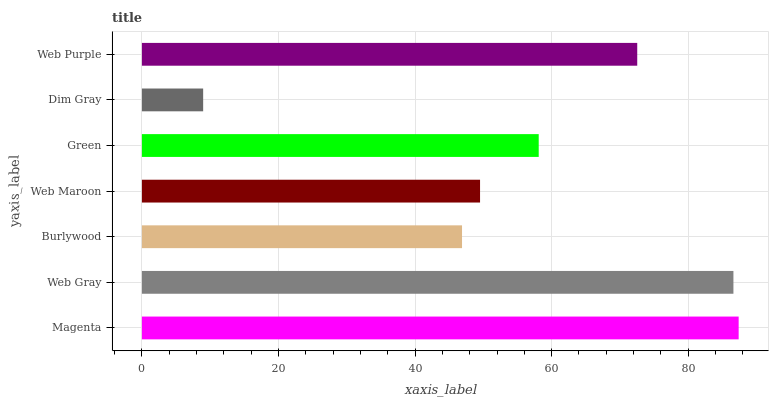Is Dim Gray the minimum?
Answer yes or no. Yes. Is Magenta the maximum?
Answer yes or no. Yes. Is Web Gray the minimum?
Answer yes or no. No. Is Web Gray the maximum?
Answer yes or no. No. Is Magenta greater than Web Gray?
Answer yes or no. Yes. Is Web Gray less than Magenta?
Answer yes or no. Yes. Is Web Gray greater than Magenta?
Answer yes or no. No. Is Magenta less than Web Gray?
Answer yes or no. No. Is Green the high median?
Answer yes or no. Yes. Is Green the low median?
Answer yes or no. Yes. Is Web Gray the high median?
Answer yes or no. No. Is Web Purple the low median?
Answer yes or no. No. 